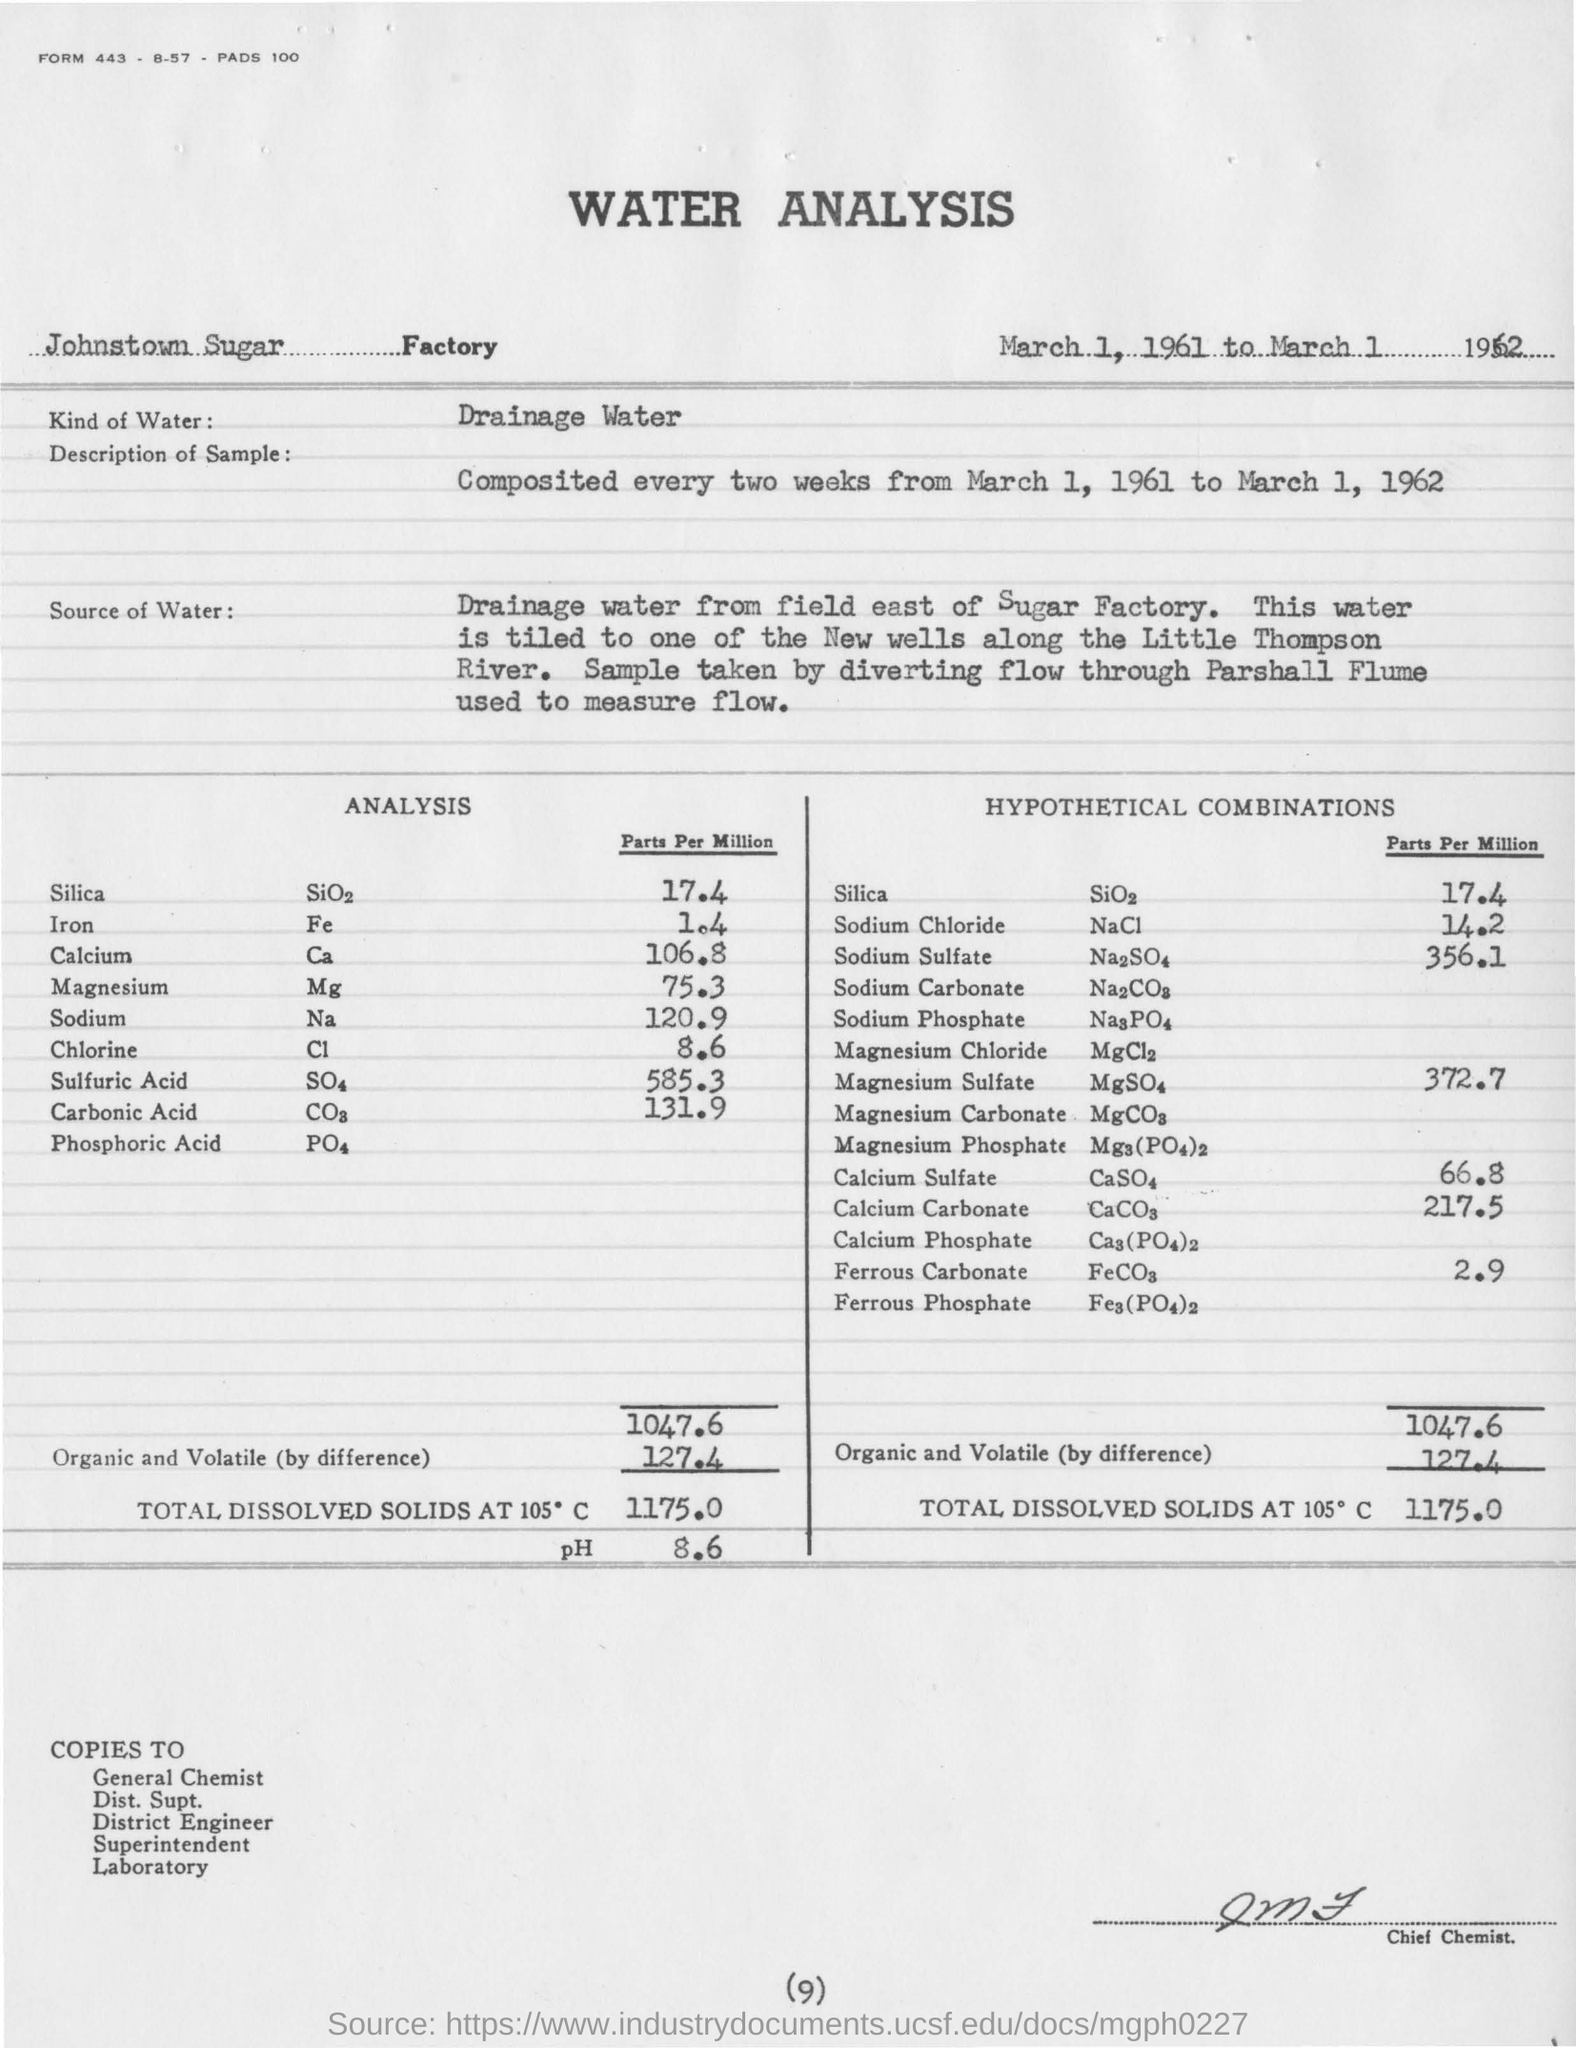What analysis is mentioned in this document?
Offer a terse response. Water Analysis. In which Factory is the analysis conducted?
Ensure brevity in your answer.  Johnstown Sugar Factory. What kind of water is used for analysis?
Provide a succinct answer. Drainage water. What is the description of sample taken?
Ensure brevity in your answer.  Composited every two weeks from March 1, 1961 to March 1, 1962. What is the volume of Fe (Parts per Million) in sample?
Offer a very short reply. 1.4. What is the volume of Chlorine (Parts per Million) in the sample?
Provide a succinct answer. 8.6. What is the page no mentioned in this document?
Keep it short and to the point. 9. What is the volume of Magnesium Sulfate (Parts per Million) in the sample?
Offer a terse response. 372.7. 